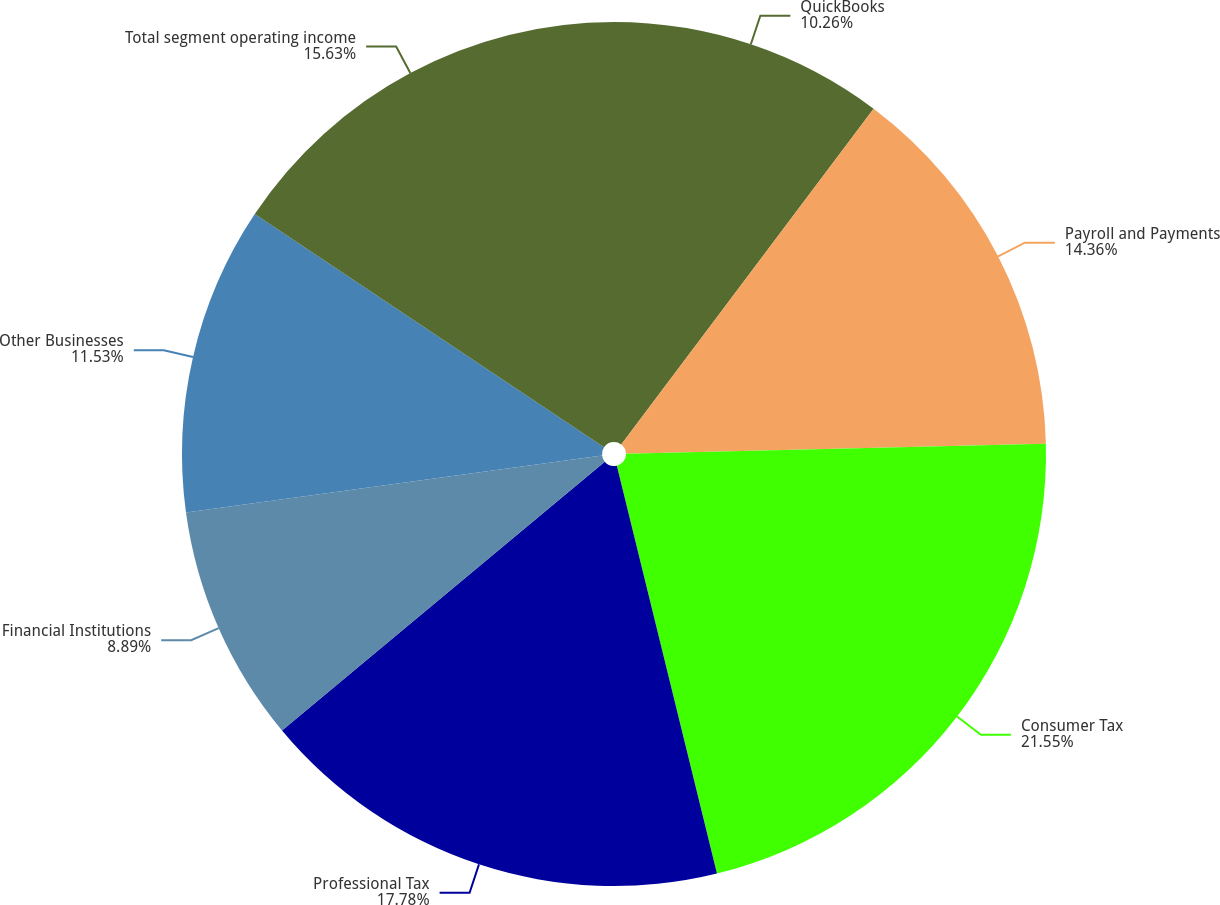Convert chart. <chart><loc_0><loc_0><loc_500><loc_500><pie_chart><fcel>QuickBooks<fcel>Payroll and Payments<fcel>Consumer Tax<fcel>Professional Tax<fcel>Financial Institutions<fcel>Other Businesses<fcel>Total segment operating income<nl><fcel>10.26%<fcel>14.36%<fcel>21.55%<fcel>17.78%<fcel>8.89%<fcel>11.53%<fcel>15.63%<nl></chart> 